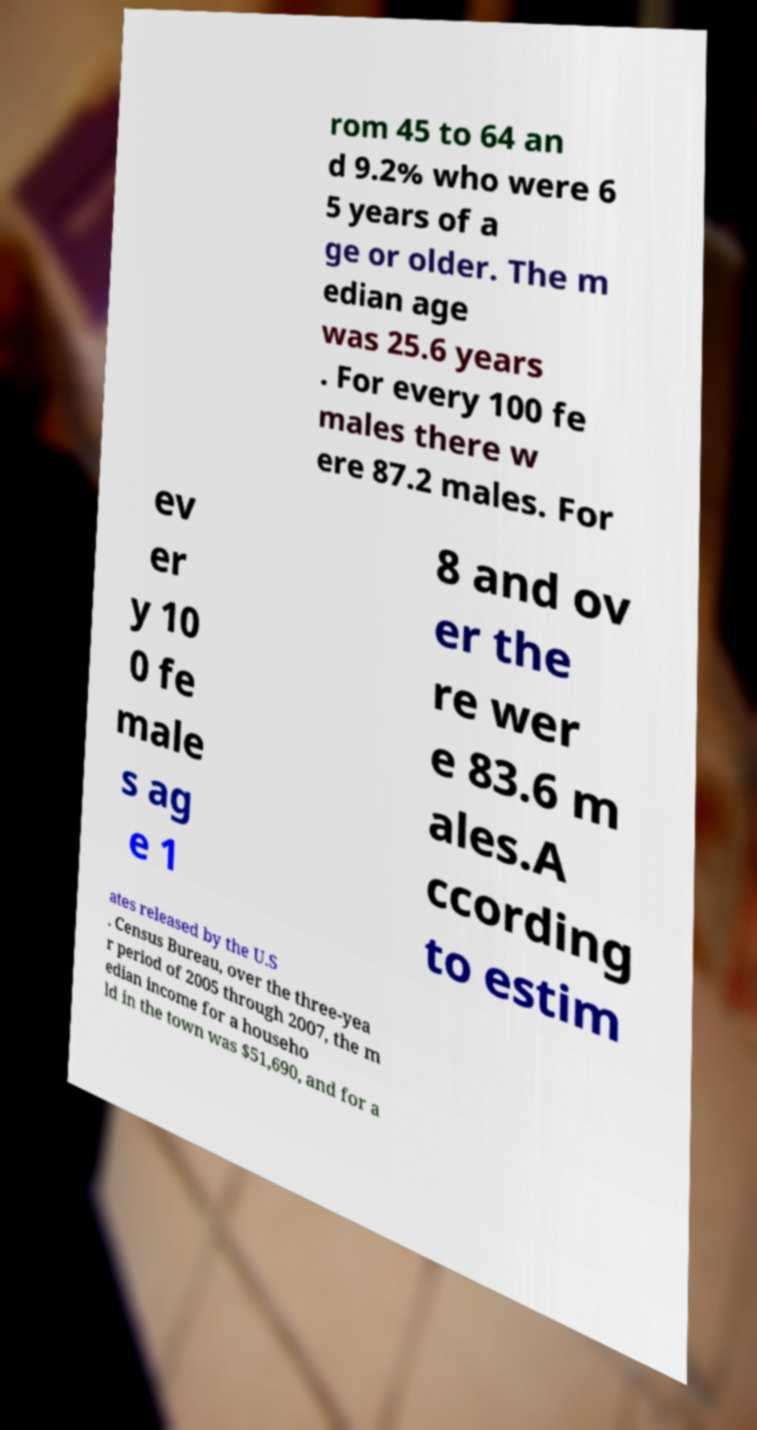Can you read and provide the text displayed in the image?This photo seems to have some interesting text. Can you extract and type it out for me? rom 45 to 64 an d 9.2% who were 6 5 years of a ge or older. The m edian age was 25.6 years . For every 100 fe males there w ere 87.2 males. For ev er y 10 0 fe male s ag e 1 8 and ov er the re wer e 83.6 m ales.A ccording to estim ates released by the U.S . Census Bureau, over the three-yea r period of 2005 through 2007, the m edian income for a househo ld in the town was $51,690, and for a 